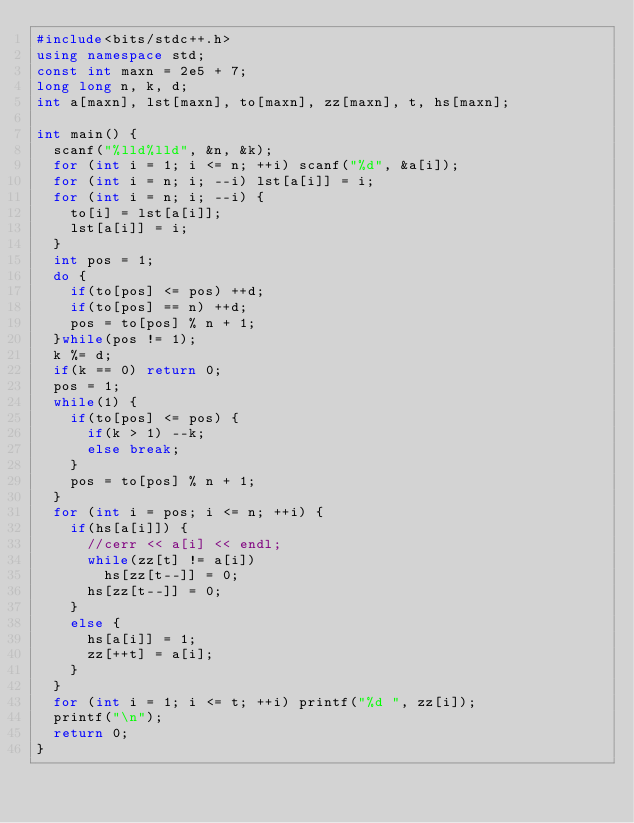Convert code to text. <code><loc_0><loc_0><loc_500><loc_500><_C++_>#include<bits/stdc++.h>
using namespace std;
const int maxn = 2e5 + 7;
long long n, k, d;
int a[maxn], lst[maxn], to[maxn], zz[maxn], t, hs[maxn];

int main() {
	scanf("%lld%lld", &n, &k);
	for (int i = 1; i <= n; ++i) scanf("%d", &a[i]);
	for (int i = n; i; --i) lst[a[i]] = i;
	for (int i = n; i; --i) {
		to[i] = lst[a[i]];
		lst[a[i]] = i;
	}
	int pos = 1;
	do {
		if(to[pos] <= pos) ++d;
		if(to[pos] == n) ++d;
		pos = to[pos] % n + 1;
	}while(pos != 1);
	k %= d;
	if(k == 0) return 0;
	pos = 1;
	while(1) {
		if(to[pos] <= pos) {
			if(k > 1) --k;
			else break;
		}
		pos = to[pos] % n + 1;
	}
	for (int i = pos; i <= n; ++i) {
		if(hs[a[i]]) {
			//cerr << a[i] << endl;
			while(zz[t] != a[i]) 
				hs[zz[t--]] = 0;
			hs[zz[t--]] = 0;
		}
		else {
			hs[a[i]] = 1;
			zz[++t] = a[i];
		}
	}
	for (int i = 1; i <= t; ++i) printf("%d ", zz[i]);
	printf("\n");
	return 0;
}</code> 